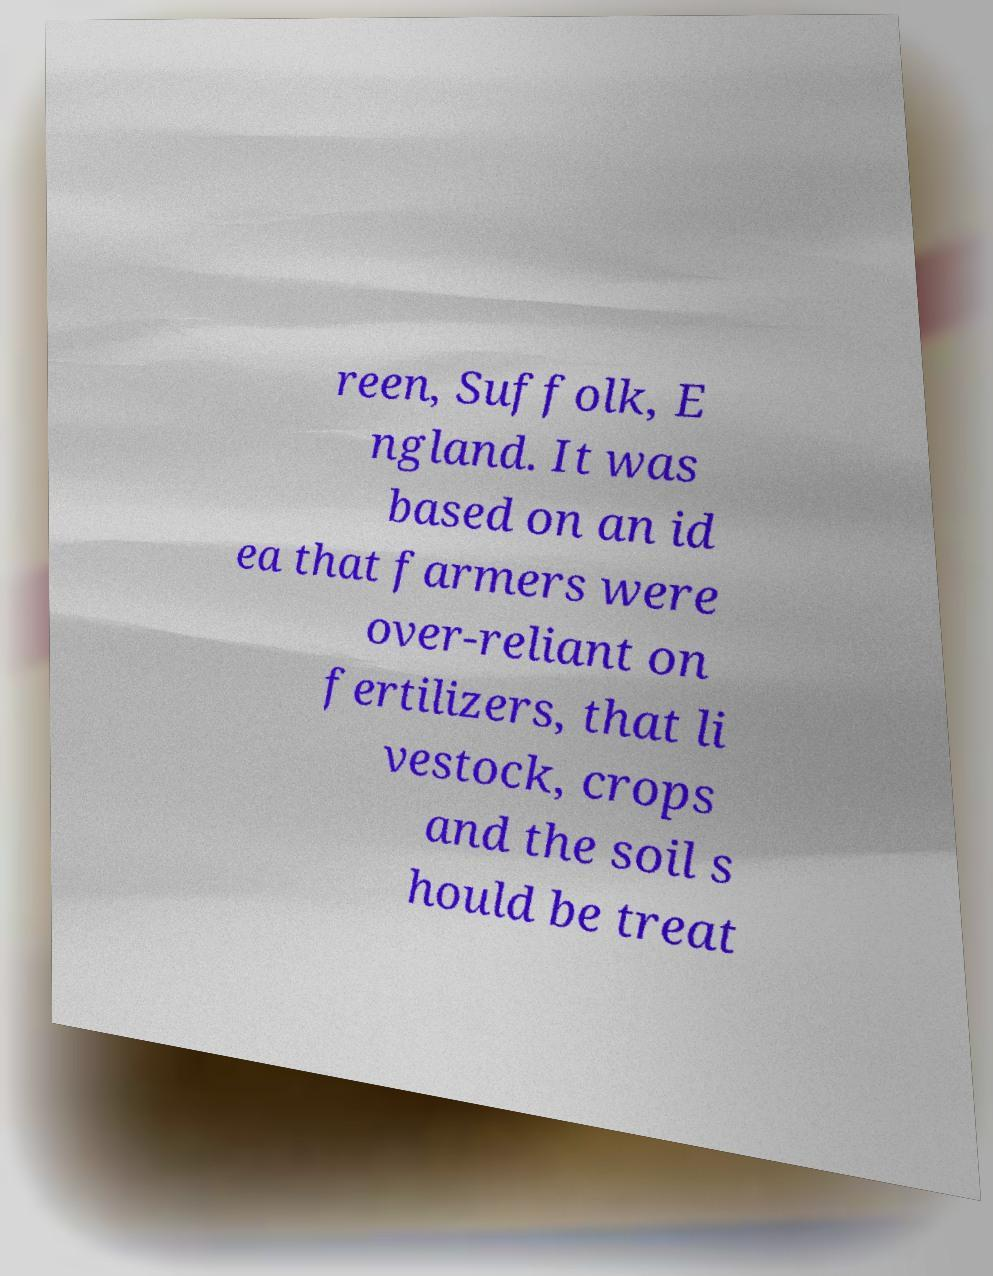I need the written content from this picture converted into text. Can you do that? reen, Suffolk, E ngland. It was based on an id ea that farmers were over-reliant on fertilizers, that li vestock, crops and the soil s hould be treat 